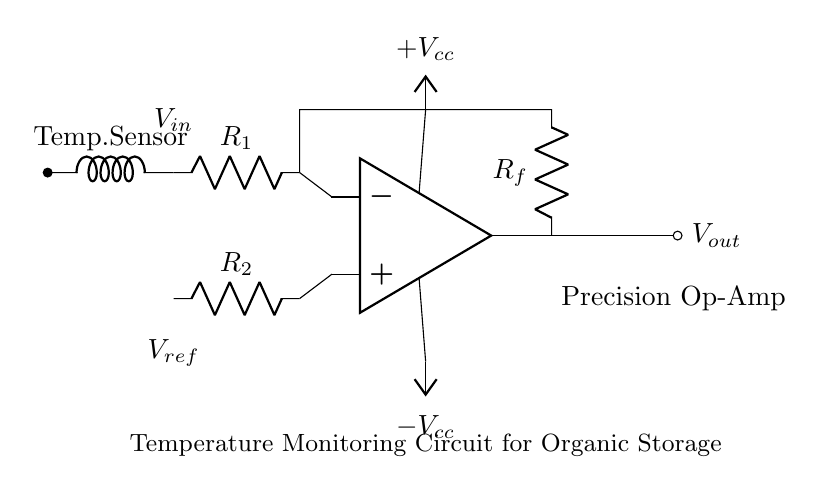What type of amplifier is used in this circuit? This circuit utilizes a precision operational amplifier, which is indicated by the op-amp symbol in the diagram.
Answer: Precision operational amplifier What is the purpose of the temperature sensor in this circuit? The temperature sensor is designed to monitor temperature variations, providing an input voltage that reflects the temperature conditions in the organic storage facility.
Answer: Monitor temperature What is the output voltage denoted as in this circuit? The output voltage of the operational amplifier circuit is labeled as V out, which is the result of the amplification process applied to the input signals from the temperature sensor and reference voltage.
Answer: V out What is the value of R f in this circuit? The value of R f is not explicitly stated in the diagram, but it represents the feedback resistor for the operational amplifier, affecting the gain of the circuit.
Answer: R f (not specified) How does the input voltage connect to the op-amp? The input voltage, labeled as V in, connects to the inverting input terminal of the operational amplifier through a resistor R 1, indicating a feedback mechanism for amplification.
Answer: Through R 1 What type of configuration is used for the op-amp in this circuit? The operational amplifier is configured in a differential mode, as it combines the inputs from both the temperature sensor and a reference voltage to determine the output.
Answer: Differential mode What power supply voltages are provided to the op-amp? The operational amplifier is powered by plus V cc and minus V cc, indicating dual power supply requirements typically needed for precision op-amps to operate effectively.
Answer: Plus V cc and minus V cc 